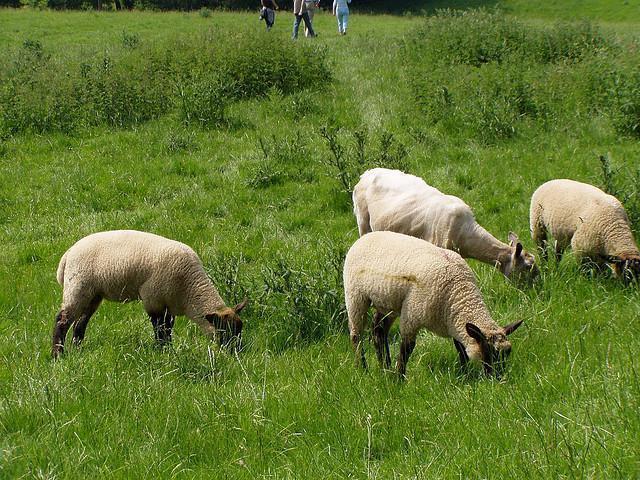How many species are in this image?
Choose the right answer from the provided options to respond to the question.
Options: Seven, two, three, five. Two. 